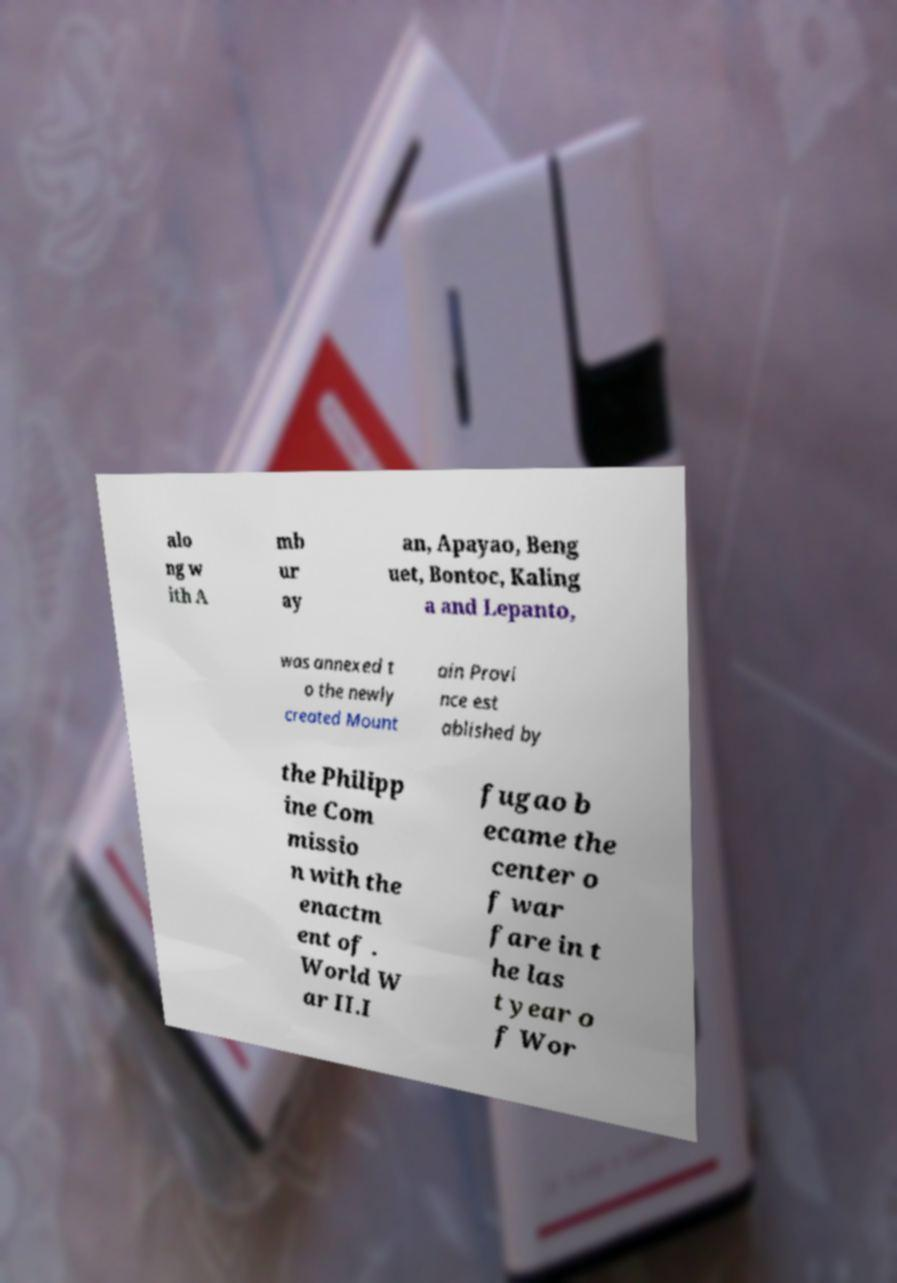What messages or text are displayed in this image? I need them in a readable, typed format. alo ng w ith A mb ur ay an, Apayao, Beng uet, Bontoc, Kaling a and Lepanto, was annexed t o the newly created Mount ain Provi nce est ablished by the Philipp ine Com missio n with the enactm ent of . World W ar II.I fugao b ecame the center o f war fare in t he las t year o f Wor 